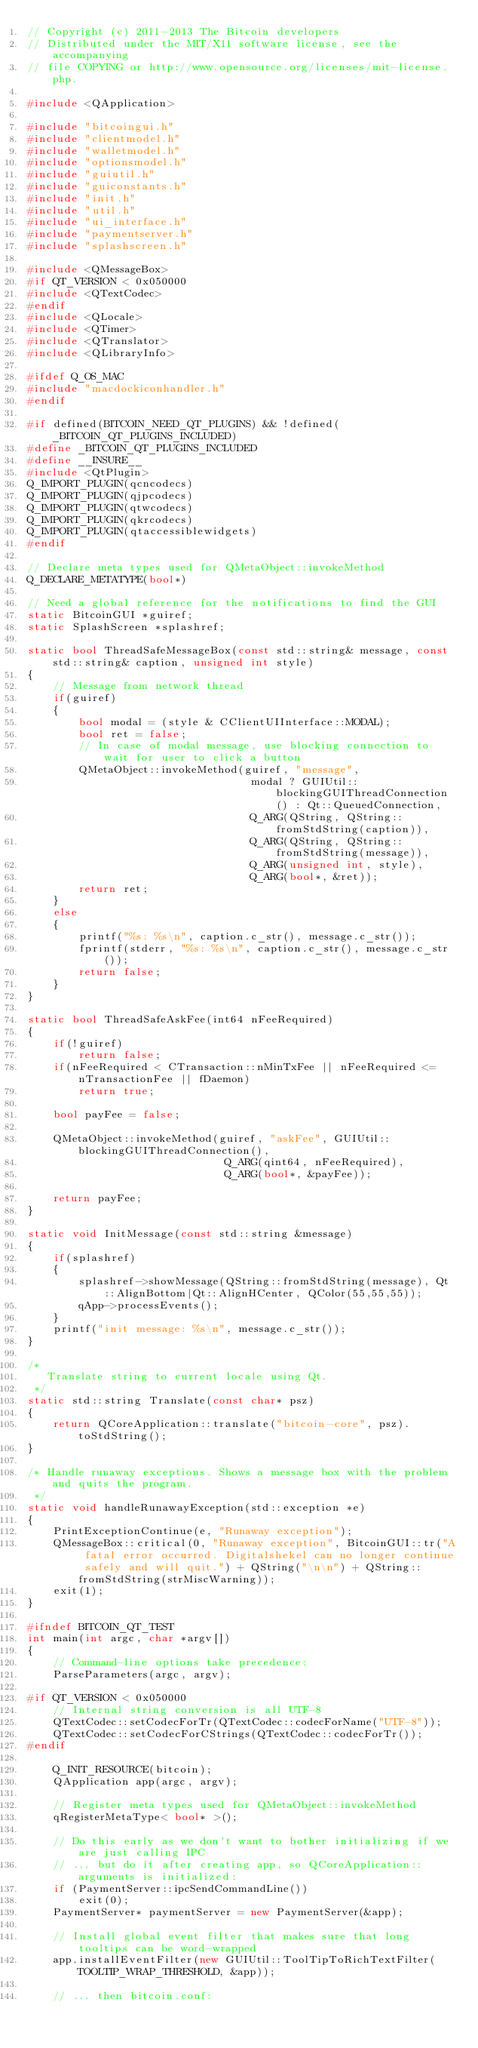Convert code to text. <code><loc_0><loc_0><loc_500><loc_500><_C++_>// Copyright (c) 2011-2013 The Bitcoin developers
// Distributed under the MIT/X11 software license, see the accompanying
// file COPYING or http://www.opensource.org/licenses/mit-license.php.

#include <QApplication>

#include "bitcoingui.h"
#include "clientmodel.h"
#include "walletmodel.h"
#include "optionsmodel.h"
#include "guiutil.h"
#include "guiconstants.h"
#include "init.h"
#include "util.h"
#include "ui_interface.h"
#include "paymentserver.h"
#include "splashscreen.h"

#include <QMessageBox>
#if QT_VERSION < 0x050000
#include <QTextCodec>
#endif
#include <QLocale>
#include <QTimer>
#include <QTranslator>
#include <QLibraryInfo>

#ifdef Q_OS_MAC
#include "macdockiconhandler.h"
#endif

#if defined(BITCOIN_NEED_QT_PLUGINS) && !defined(_BITCOIN_QT_PLUGINS_INCLUDED)
#define _BITCOIN_QT_PLUGINS_INCLUDED
#define __INSURE__
#include <QtPlugin>
Q_IMPORT_PLUGIN(qcncodecs)
Q_IMPORT_PLUGIN(qjpcodecs)
Q_IMPORT_PLUGIN(qtwcodecs)
Q_IMPORT_PLUGIN(qkrcodecs)
Q_IMPORT_PLUGIN(qtaccessiblewidgets)
#endif

// Declare meta types used for QMetaObject::invokeMethod
Q_DECLARE_METATYPE(bool*)

// Need a global reference for the notifications to find the GUI
static BitcoinGUI *guiref;
static SplashScreen *splashref;

static bool ThreadSafeMessageBox(const std::string& message, const std::string& caption, unsigned int style)
{
    // Message from network thread
    if(guiref)
    {
        bool modal = (style & CClientUIInterface::MODAL);
        bool ret = false;
        // In case of modal message, use blocking connection to wait for user to click a button
        QMetaObject::invokeMethod(guiref, "message",
                                   modal ? GUIUtil::blockingGUIThreadConnection() : Qt::QueuedConnection,
                                   Q_ARG(QString, QString::fromStdString(caption)),
                                   Q_ARG(QString, QString::fromStdString(message)),
                                   Q_ARG(unsigned int, style),
                                   Q_ARG(bool*, &ret));
        return ret;
    }
    else
    {
        printf("%s: %s\n", caption.c_str(), message.c_str());
        fprintf(stderr, "%s: %s\n", caption.c_str(), message.c_str());
        return false;
    }
}

static bool ThreadSafeAskFee(int64 nFeeRequired)
{
    if(!guiref)
        return false;
    if(nFeeRequired < CTransaction::nMinTxFee || nFeeRequired <= nTransactionFee || fDaemon)
        return true;

    bool payFee = false;

    QMetaObject::invokeMethod(guiref, "askFee", GUIUtil::blockingGUIThreadConnection(),
                               Q_ARG(qint64, nFeeRequired),
                               Q_ARG(bool*, &payFee));

    return payFee;
}

static void InitMessage(const std::string &message)
{
    if(splashref)
    {
        splashref->showMessage(QString::fromStdString(message), Qt::AlignBottom|Qt::AlignHCenter, QColor(55,55,55));
        qApp->processEvents();
    }
    printf("init message: %s\n", message.c_str());
}

/*
   Translate string to current locale using Qt.
 */
static std::string Translate(const char* psz)
{
    return QCoreApplication::translate("bitcoin-core", psz).toStdString();
}

/* Handle runaway exceptions. Shows a message box with the problem and quits the program.
 */
static void handleRunawayException(std::exception *e)
{
    PrintExceptionContinue(e, "Runaway exception");
    QMessageBox::critical(0, "Runaway exception", BitcoinGUI::tr("A fatal error occurred. Digitalshekel can no longer continue safely and will quit.") + QString("\n\n") + QString::fromStdString(strMiscWarning));
    exit(1);
}

#ifndef BITCOIN_QT_TEST
int main(int argc, char *argv[])
{
    // Command-line options take precedence:
    ParseParameters(argc, argv);

#if QT_VERSION < 0x050000
    // Internal string conversion is all UTF-8
    QTextCodec::setCodecForTr(QTextCodec::codecForName("UTF-8"));
    QTextCodec::setCodecForCStrings(QTextCodec::codecForTr());
#endif

    Q_INIT_RESOURCE(bitcoin);
    QApplication app(argc, argv);

    // Register meta types used for QMetaObject::invokeMethod
    qRegisterMetaType< bool* >();

    // Do this early as we don't want to bother initializing if we are just calling IPC
    // ... but do it after creating app, so QCoreApplication::arguments is initialized:
    if (PaymentServer::ipcSendCommandLine())
        exit(0);
    PaymentServer* paymentServer = new PaymentServer(&app);

    // Install global event filter that makes sure that long tooltips can be word-wrapped
    app.installEventFilter(new GUIUtil::ToolTipToRichTextFilter(TOOLTIP_WRAP_THRESHOLD, &app));

    // ... then bitcoin.conf:</code> 